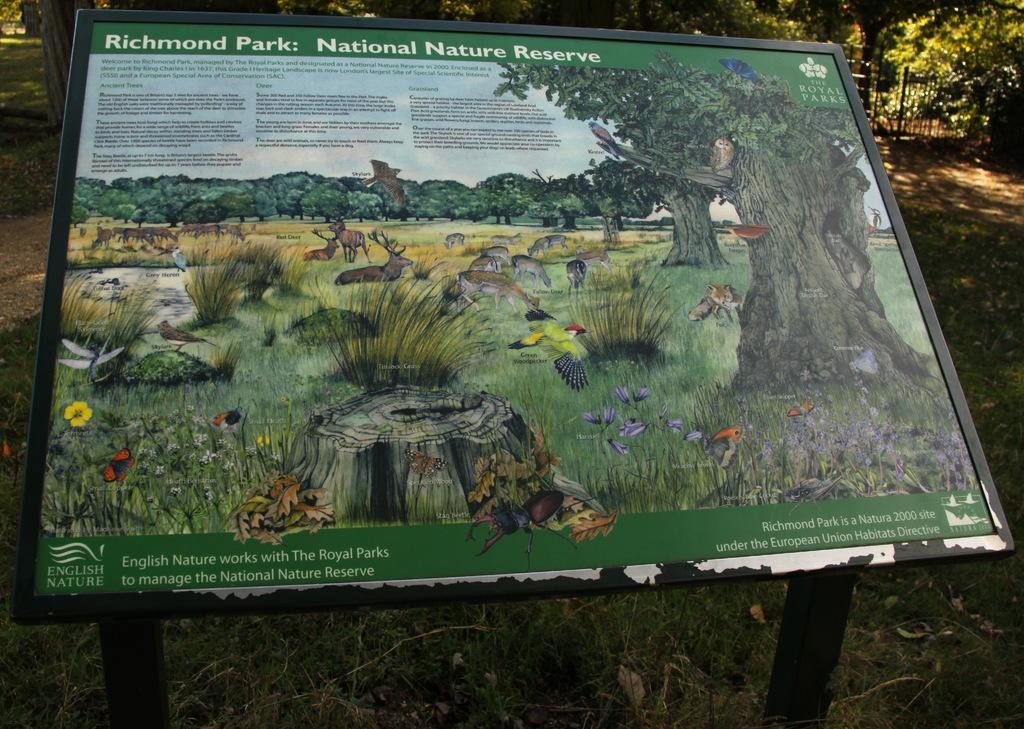What is the main object in the center of the image? There is a board in the center of the image. What can be seen in the distance behind the board? There are trees in the background of the image. What type of ground is visible at the bottom of the image? There is grass at the bottom of the image. What type of plant is the mitten growing on in the image? There is no mitten or plant present in the image. 